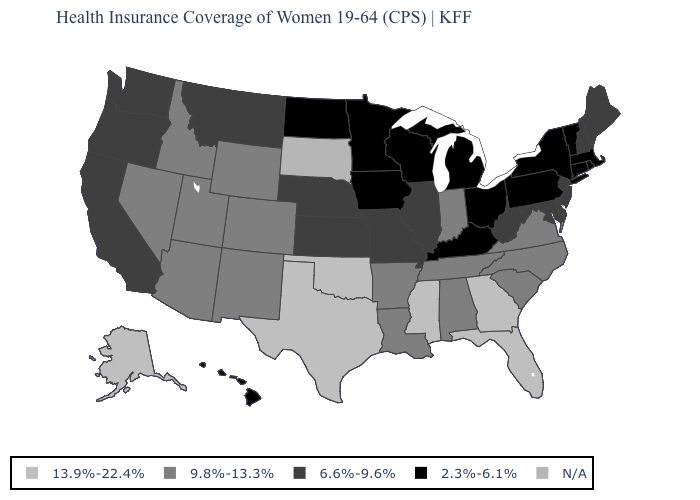Name the states that have a value in the range N/A?
Answer briefly. South Dakota. Which states have the highest value in the USA?
Quick response, please. Alaska, Florida, Georgia, Mississippi, Oklahoma, Texas. Among the states that border South Dakota , which have the lowest value?
Quick response, please. Iowa, Minnesota, North Dakota. What is the value of Montana?
Be succinct. 6.6%-9.6%. Name the states that have a value in the range 9.8%-13.3%?
Concise answer only. Alabama, Arizona, Arkansas, Colorado, Idaho, Indiana, Louisiana, Nevada, New Mexico, North Carolina, South Carolina, Tennessee, Utah, Virginia, Wyoming. Among the states that border Illinois , which have the highest value?
Answer briefly. Indiana. What is the highest value in the South ?
Write a very short answer. 13.9%-22.4%. Is the legend a continuous bar?
Quick response, please. No. Does Kentucky have the lowest value in the South?
Concise answer only. Yes. Name the states that have a value in the range N/A?
Quick response, please. South Dakota. Name the states that have a value in the range N/A?
Quick response, please. South Dakota. What is the highest value in states that border Kansas?
Concise answer only. 13.9%-22.4%. What is the lowest value in the USA?
Be succinct. 2.3%-6.1%. What is the highest value in the West ?
Give a very brief answer. 13.9%-22.4%. 